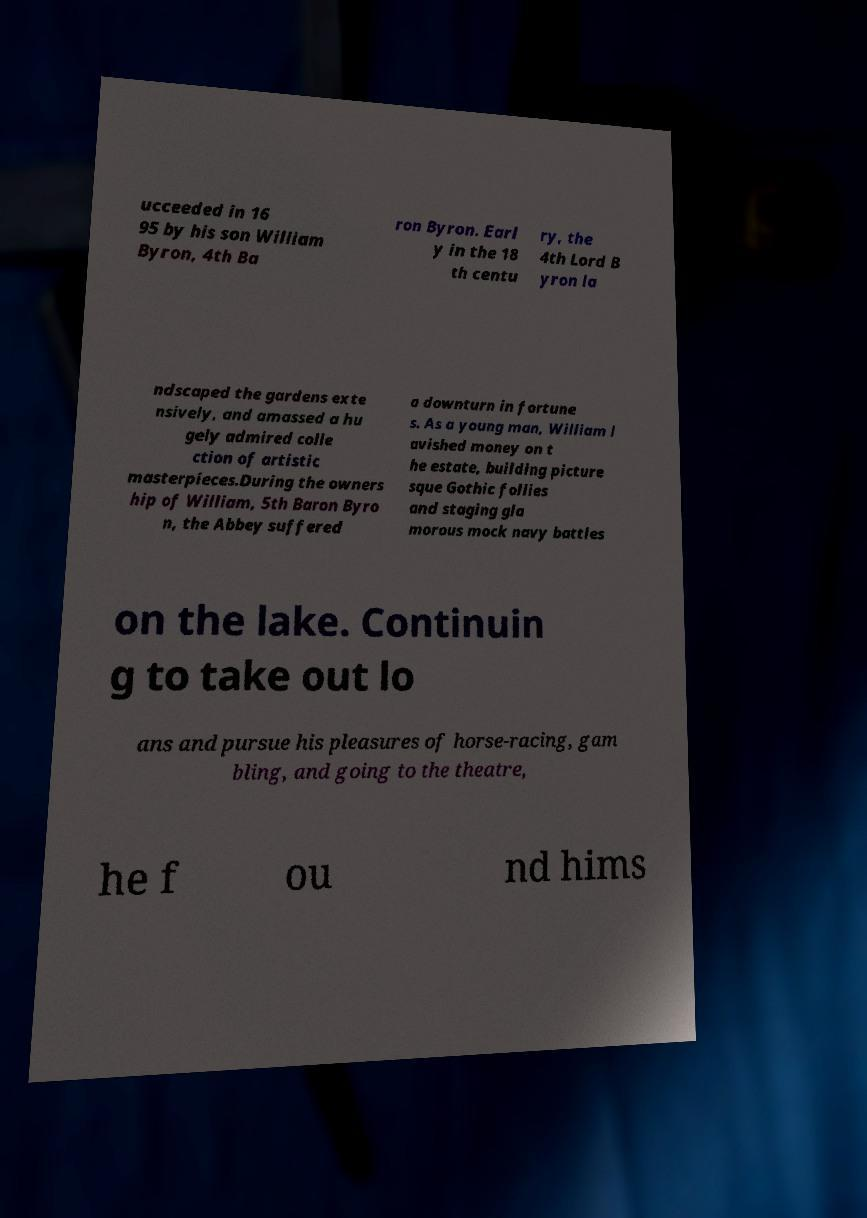For documentation purposes, I need the text within this image transcribed. Could you provide that? ucceeded in 16 95 by his son William Byron, 4th Ba ron Byron. Earl y in the 18 th centu ry, the 4th Lord B yron la ndscaped the gardens exte nsively, and amassed a hu gely admired colle ction of artistic masterpieces.During the owners hip of William, 5th Baron Byro n, the Abbey suffered a downturn in fortune s. As a young man, William l avished money on t he estate, building picture sque Gothic follies and staging gla morous mock navy battles on the lake. Continuin g to take out lo ans and pursue his pleasures of horse-racing, gam bling, and going to the theatre, he f ou nd hims 